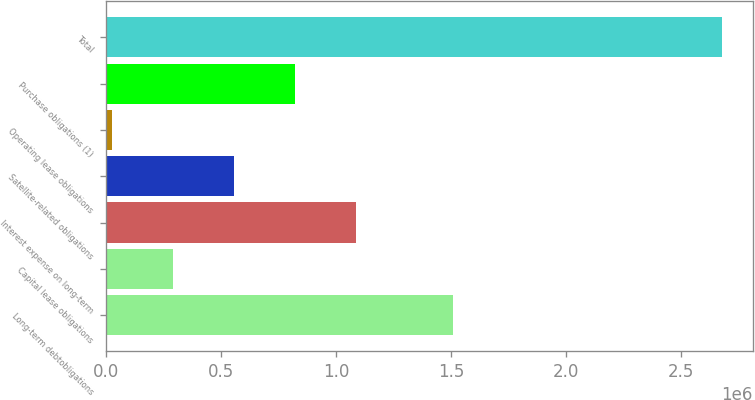Convert chart to OTSL. <chart><loc_0><loc_0><loc_500><loc_500><bar_chart><fcel>Long-term debtobligations<fcel>Capital lease obligations<fcel>Interest expense on long-term<fcel>Satellite-related obligations<fcel>Operating lease obligations<fcel>Purchase obligations (1)<fcel>Total<nl><fcel>1.50674e+06<fcel>288270<fcel>1.08445e+06<fcel>553662<fcel>22878<fcel>819054<fcel>2.6768e+06<nl></chart> 